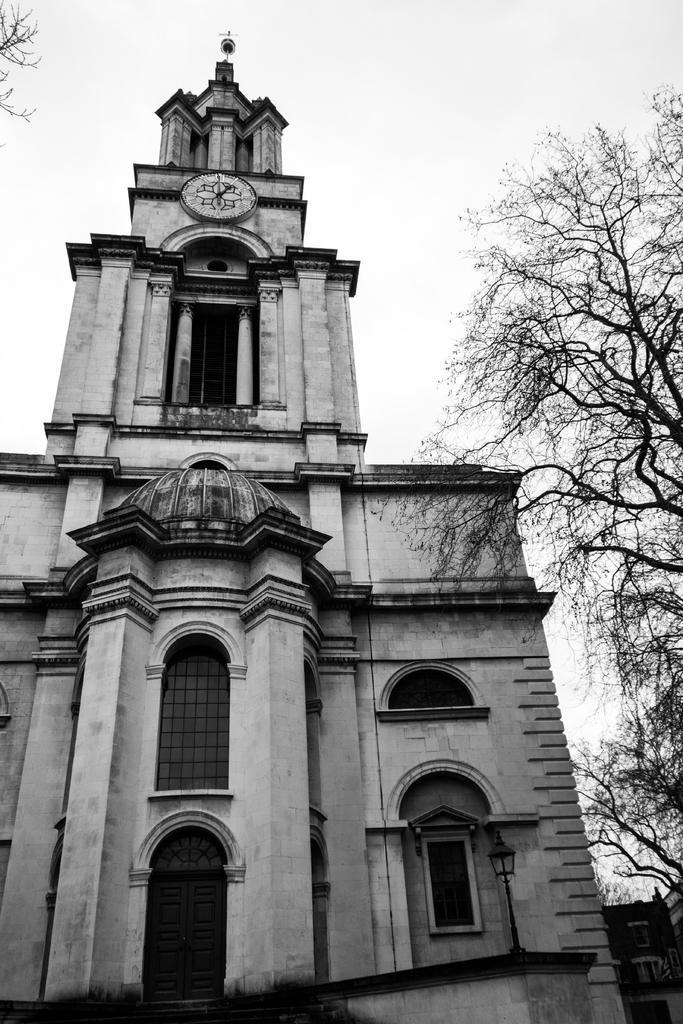Describe this image in one or two sentences. In the picture we can see a historical building and beside it, we can see a tree which is dried and behind it we can see a sky. 